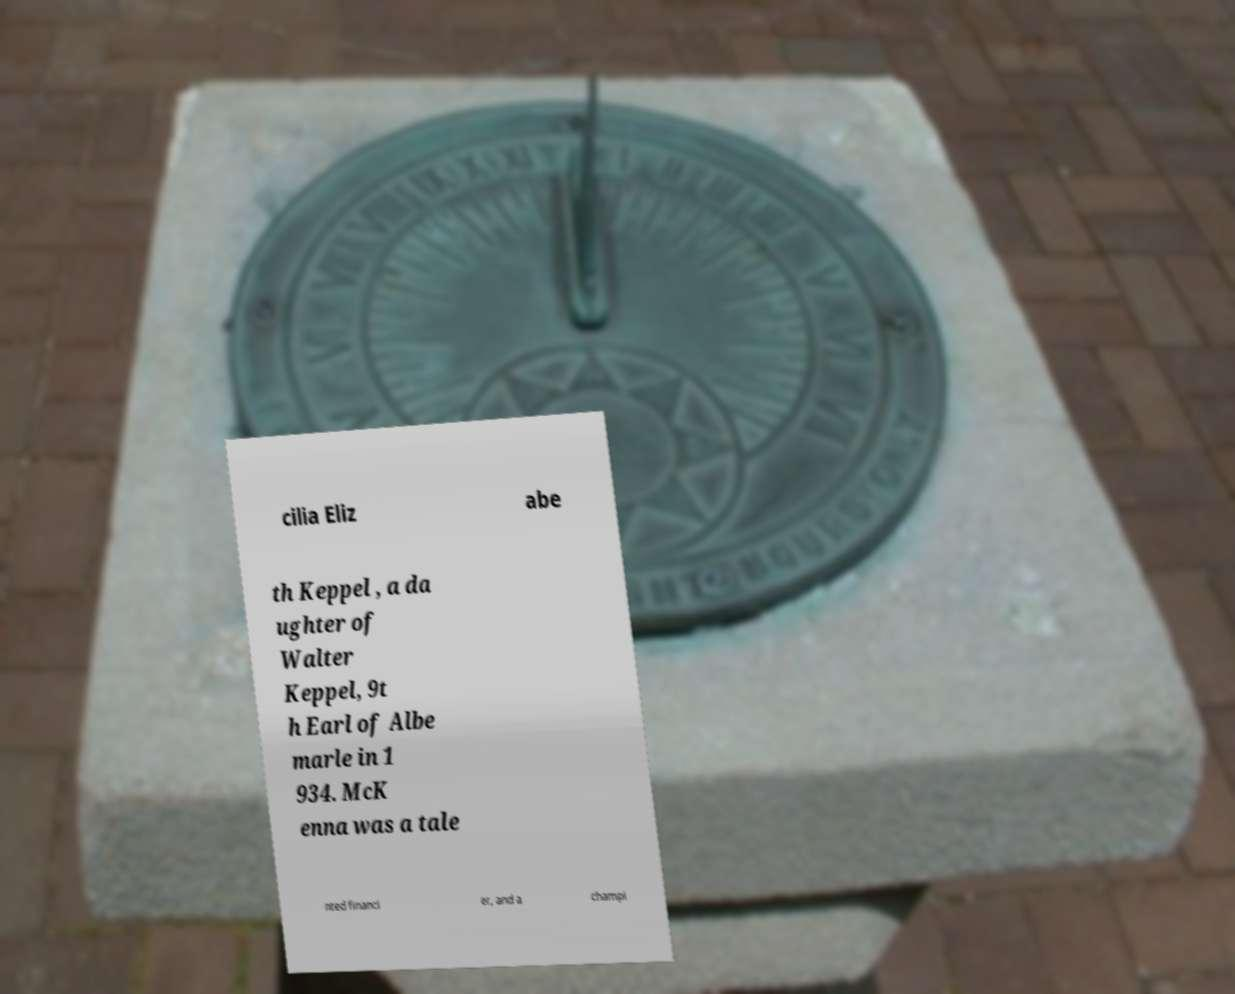Please identify and transcribe the text found in this image. cilia Eliz abe th Keppel , a da ughter of Walter Keppel, 9t h Earl of Albe marle in 1 934. McK enna was a tale nted financi er, and a champi 